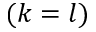<formula> <loc_0><loc_0><loc_500><loc_500>( k = l )</formula> 